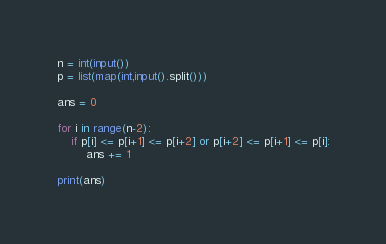<code> <loc_0><loc_0><loc_500><loc_500><_Python_>n = int(input())
p = list(map(int,input().split()))

ans = 0

for i in range(n-2):
    if p[i] <= p[i+1] <= p[i+2] or p[i+2] <= p[i+1] <= p[i]:
        ans += 1

print(ans)</code> 